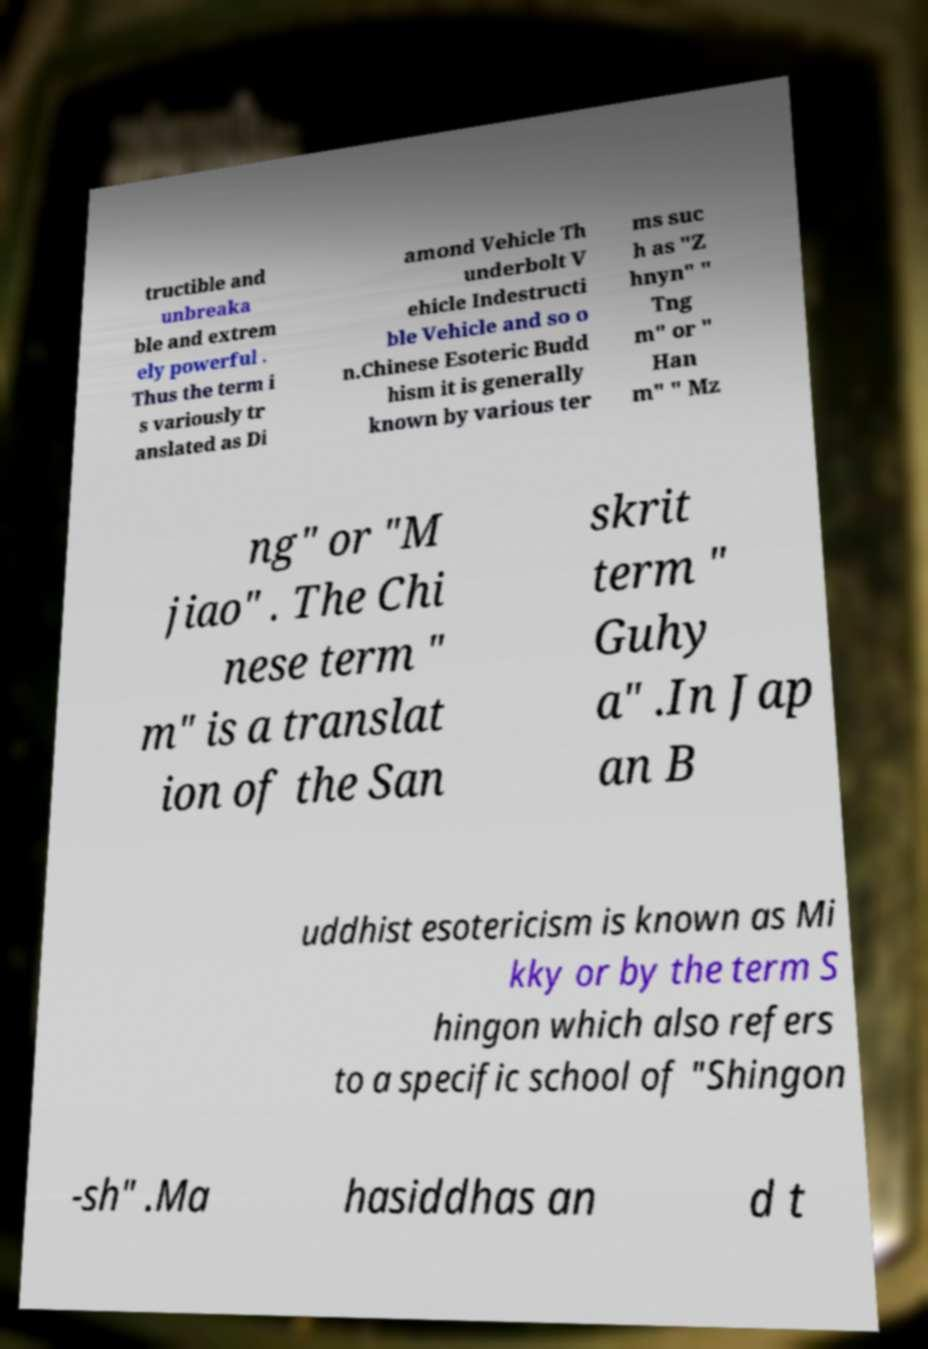Could you assist in decoding the text presented in this image and type it out clearly? tructible and unbreaka ble and extrem ely powerful . Thus the term i s variously tr anslated as Di amond Vehicle Th underbolt V ehicle Indestructi ble Vehicle and so o n.Chinese Esoteric Budd hism it is generally known by various ter ms suc h as "Z hnyn" " Tng m" or " Han m" " Mz ng" or "M jiao" . The Chi nese term " m" is a translat ion of the San skrit term " Guhy a" .In Jap an B uddhist esotericism is known as Mi kky or by the term S hingon which also refers to a specific school of "Shingon -sh" .Ma hasiddhas an d t 